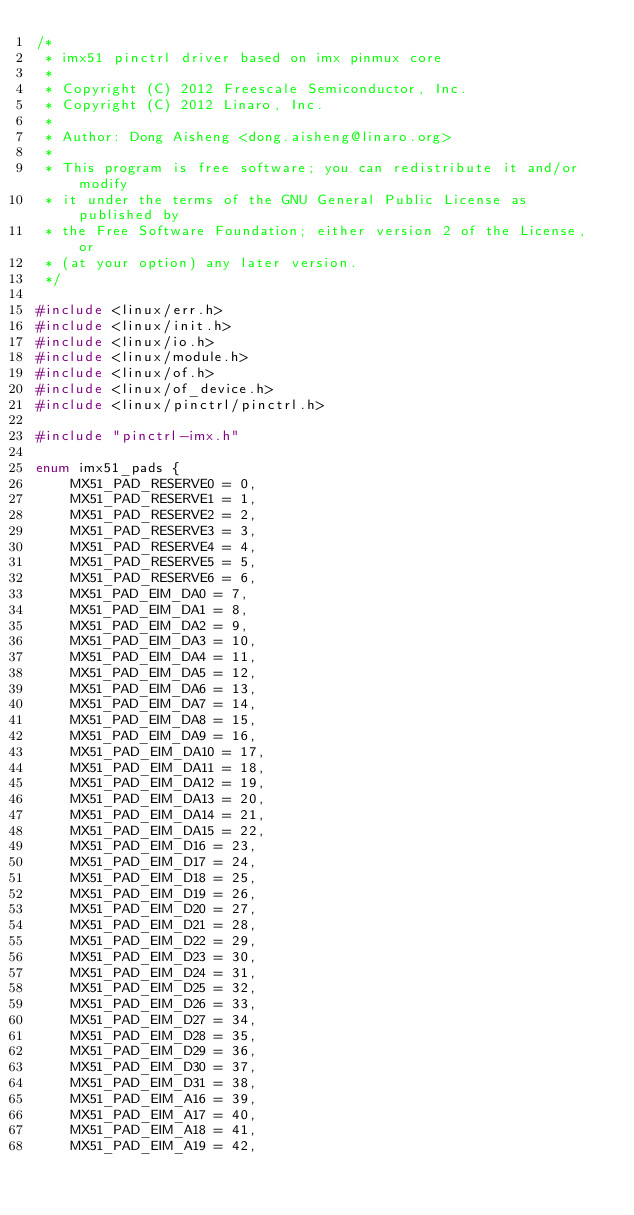Convert code to text. <code><loc_0><loc_0><loc_500><loc_500><_C_>/*
 * imx51 pinctrl driver based on imx pinmux core
 *
 * Copyright (C) 2012 Freescale Semiconductor, Inc.
 * Copyright (C) 2012 Linaro, Inc.
 *
 * Author: Dong Aisheng <dong.aisheng@linaro.org>
 *
 * This program is free software; you can redistribute it and/or modify
 * it under the terms of the GNU General Public License as published by
 * the Free Software Foundation; either version 2 of the License, or
 * (at your option) any later version.
 */

#include <linux/err.h>
#include <linux/init.h>
#include <linux/io.h>
#include <linux/module.h>
#include <linux/of.h>
#include <linux/of_device.h>
#include <linux/pinctrl/pinctrl.h>

#include "pinctrl-imx.h"

enum imx51_pads {
	MX51_PAD_RESERVE0 = 0,
	MX51_PAD_RESERVE1 = 1,
	MX51_PAD_RESERVE2 = 2,
	MX51_PAD_RESERVE3 = 3,
	MX51_PAD_RESERVE4 = 4,
	MX51_PAD_RESERVE5 = 5,
	MX51_PAD_RESERVE6 = 6,
	MX51_PAD_EIM_DA0 = 7,
	MX51_PAD_EIM_DA1 = 8,
	MX51_PAD_EIM_DA2 = 9,
	MX51_PAD_EIM_DA3 = 10,
	MX51_PAD_EIM_DA4 = 11,
	MX51_PAD_EIM_DA5 = 12,
	MX51_PAD_EIM_DA6 = 13,
	MX51_PAD_EIM_DA7 = 14,
	MX51_PAD_EIM_DA8 = 15,
	MX51_PAD_EIM_DA9 = 16,
	MX51_PAD_EIM_DA10 = 17,
	MX51_PAD_EIM_DA11 = 18,
	MX51_PAD_EIM_DA12 = 19,
	MX51_PAD_EIM_DA13 = 20,
	MX51_PAD_EIM_DA14 = 21,
	MX51_PAD_EIM_DA15 = 22,
	MX51_PAD_EIM_D16 = 23,
	MX51_PAD_EIM_D17 = 24,
	MX51_PAD_EIM_D18 = 25,
	MX51_PAD_EIM_D19 = 26,
	MX51_PAD_EIM_D20 = 27,
	MX51_PAD_EIM_D21 = 28,
	MX51_PAD_EIM_D22 = 29,
	MX51_PAD_EIM_D23 = 30,
	MX51_PAD_EIM_D24 = 31,
	MX51_PAD_EIM_D25 = 32,
	MX51_PAD_EIM_D26 = 33,
	MX51_PAD_EIM_D27 = 34,
	MX51_PAD_EIM_D28 = 35,
	MX51_PAD_EIM_D29 = 36,
	MX51_PAD_EIM_D30 = 37,
	MX51_PAD_EIM_D31 = 38,
	MX51_PAD_EIM_A16 = 39,
	MX51_PAD_EIM_A17 = 40,
	MX51_PAD_EIM_A18 = 41,
	MX51_PAD_EIM_A19 = 42,</code> 